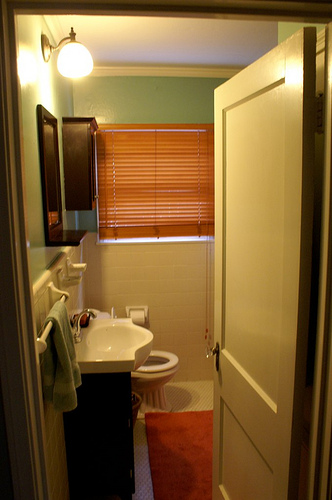Is there any source of light in the room? Yes, there are two light sources visible in the image: a lightbulb towards the top left and natural light seeping through the window blinds. 